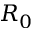Convert formula to latex. <formula><loc_0><loc_0><loc_500><loc_500>R _ { 0 }</formula> 